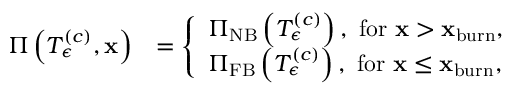Convert formula to latex. <formula><loc_0><loc_0><loc_500><loc_500>\begin{array} { r l } { \Pi \left ( T _ { \epsilon } ^ { \left ( c \right ) } , x \right ) } & { = \left \{ \begin{array} { l l } { \Pi _ { N B } \left ( T _ { \epsilon } ^ { \left ( c \right ) } \right ) , f o r x > x _ { b u r n } , } \\ { \Pi _ { F B } \left ( T _ { \epsilon } ^ { \left ( c \right ) } \right ) , f o r x \leq x _ { b u r n } , } \end{array} } \end{array}</formula> 